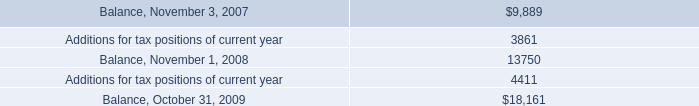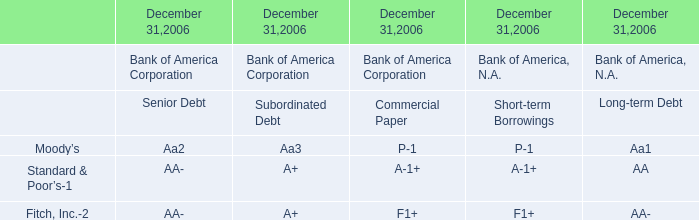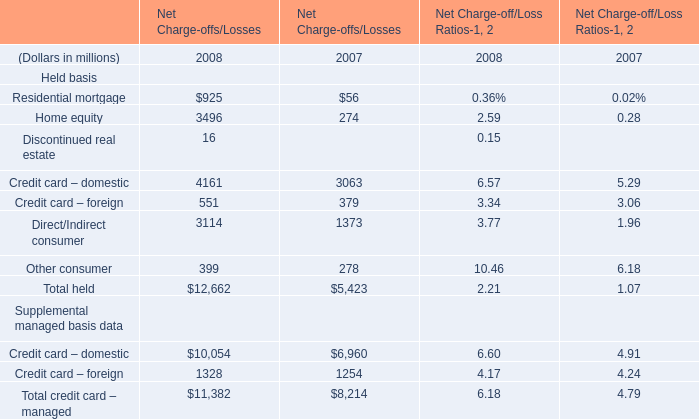What's the increasing rate of Home equity of Net Charge-offs/Losses in 2008? 
Computations: ((3496 - 274) / 274)
Answer: 11.75912. 